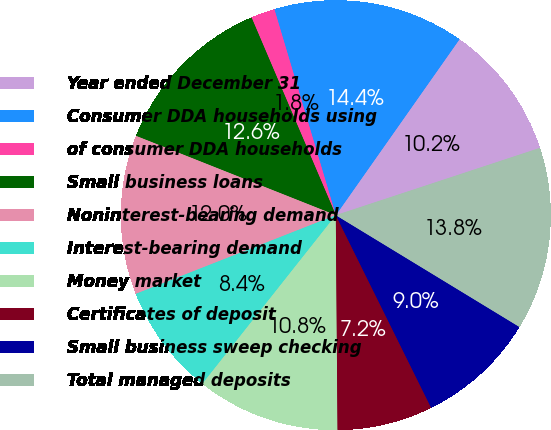Convert chart. <chart><loc_0><loc_0><loc_500><loc_500><pie_chart><fcel>Year ended December 31<fcel>Consumer DDA households using<fcel>of consumer DDA households<fcel>Small business loans<fcel>Noninterest-bearing demand<fcel>Interest-bearing demand<fcel>Money market<fcel>Certificates of deposit<fcel>Small business sweep checking<fcel>Total managed deposits<nl><fcel>10.18%<fcel>14.37%<fcel>1.8%<fcel>12.57%<fcel>11.98%<fcel>8.38%<fcel>10.78%<fcel>7.19%<fcel>8.98%<fcel>13.77%<nl></chart> 